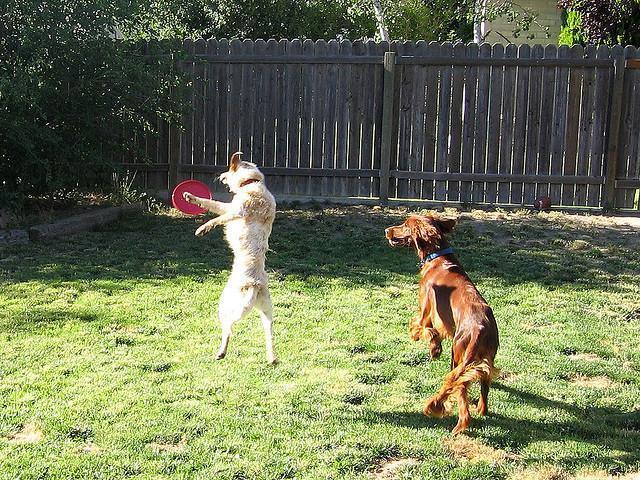How many dogs can be seen?
Give a very brief answer. 2. 